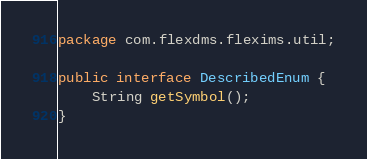<code> <loc_0><loc_0><loc_500><loc_500><_Java_>package com.flexdms.flexims.util;

public interface DescribedEnum {
	String getSymbol();
}
</code> 